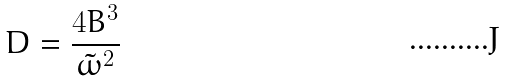<formula> <loc_0><loc_0><loc_500><loc_500>D = \frac { 4 B ^ { 3 } } { \tilde { \omega } ^ { 2 } }</formula> 